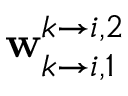<formula> <loc_0><loc_0><loc_500><loc_500>w _ { k \rightarrow i , 1 } ^ { k \rightarrow i , 2 }</formula> 